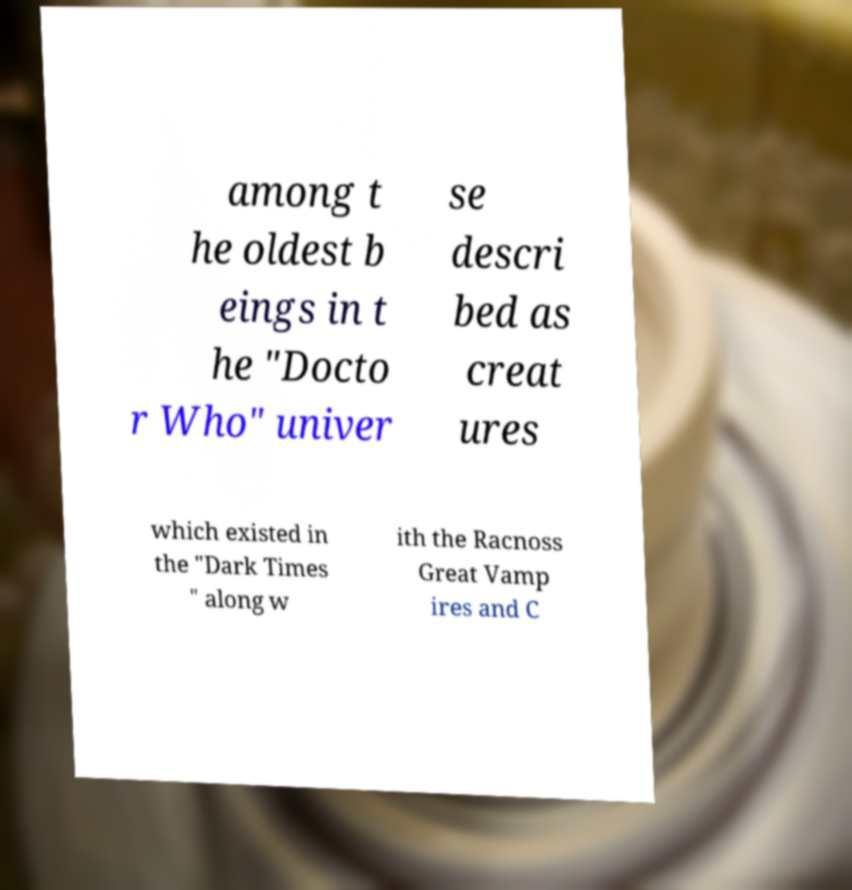Please identify and transcribe the text found in this image. among t he oldest b eings in t he "Docto r Who" univer se descri bed as creat ures which existed in the "Dark Times " along w ith the Racnoss Great Vamp ires and C 